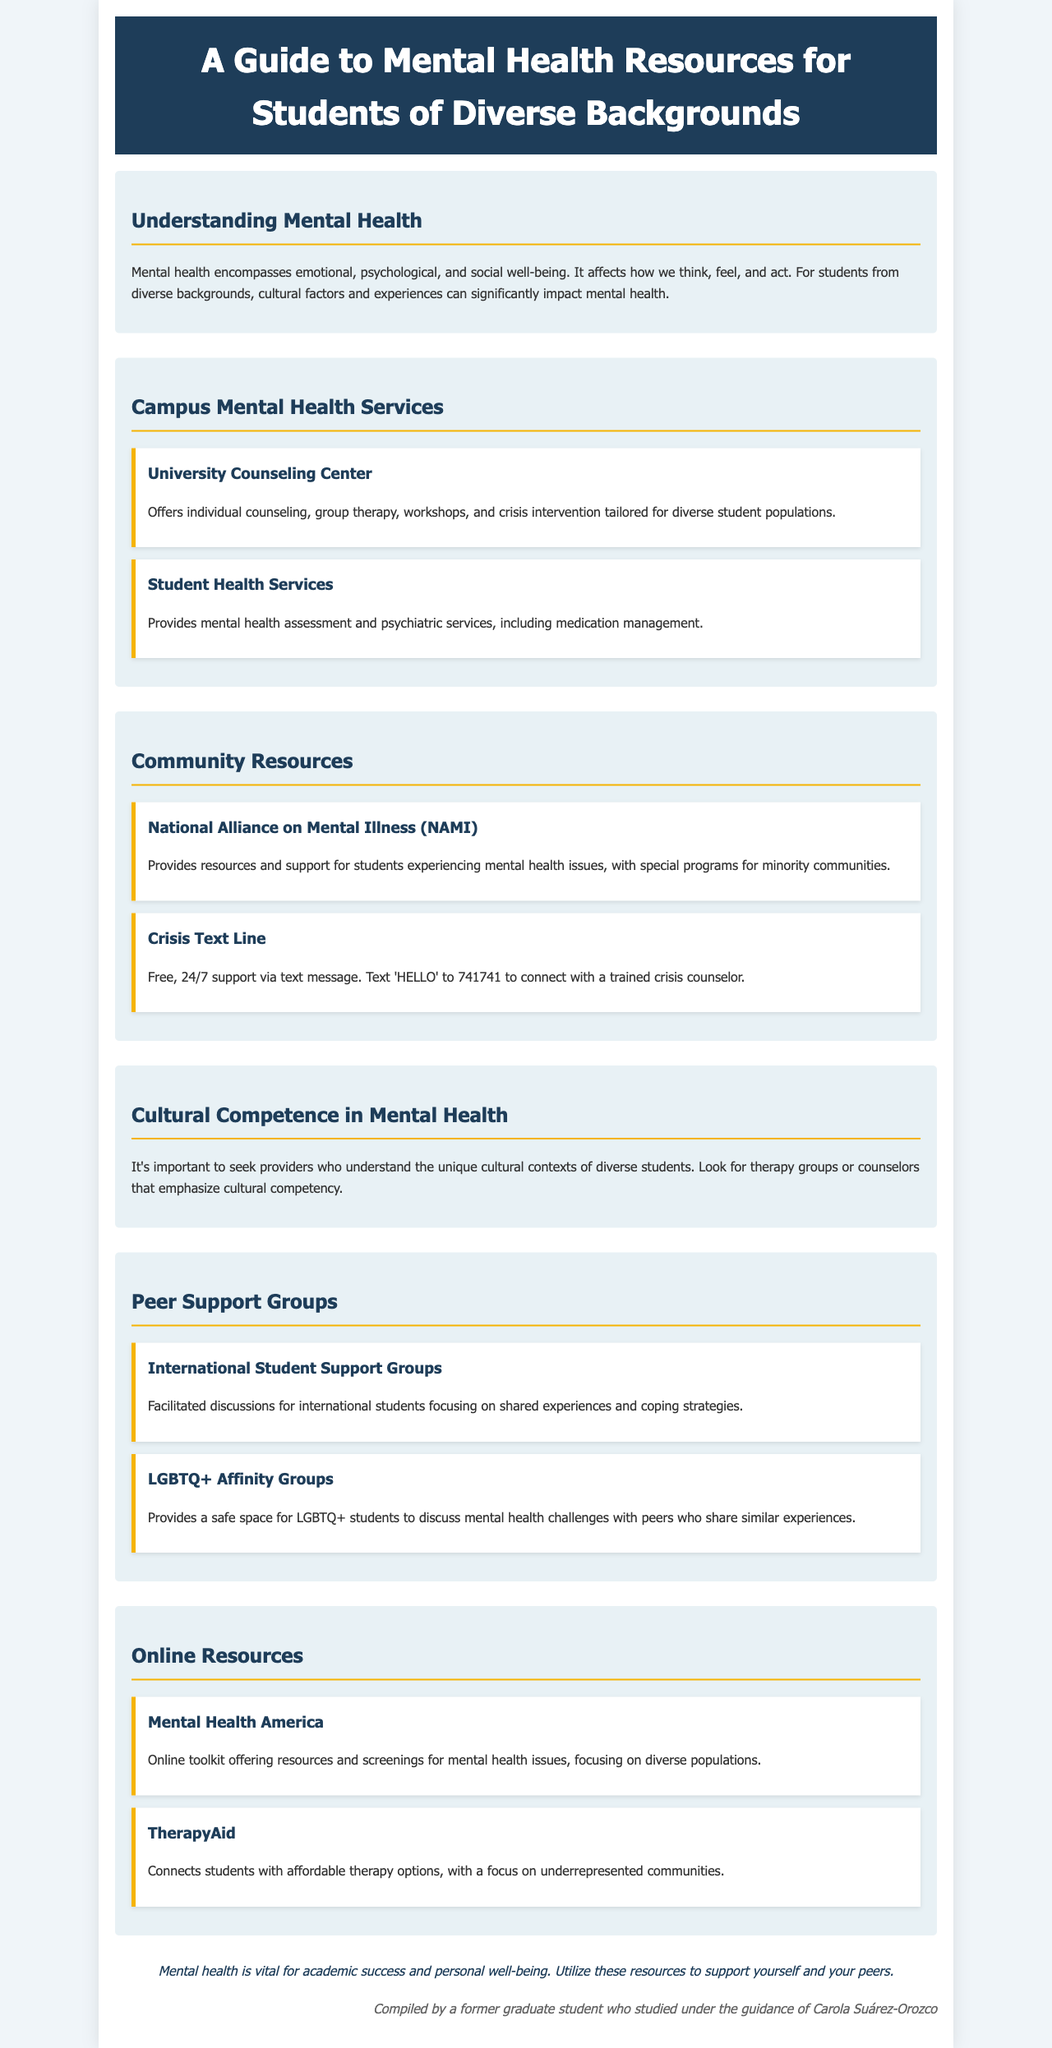What is the title of the document? The title is prominently displayed at the top of the document under the header section.
Answer: A Guide to Mental Health Resources for Students of Diverse Backgrounds What services does the University Counseling Center provide? The services provided by the University Counseling Center are detailed in the Campus Mental Health Services section.
Answer: Individual counseling, group therapy, workshops, and crisis intervention How can students connect with Crisis Text Line? The method to contact the Crisis Text Line is mentioned in the Community Resources section.
Answer: Text 'HELLO' to 741741 What type of support do the LGBTQ+ Affinity Groups offer? The type of support provided is described in the Peer Support Groups section.
Answer: A safe space for LGBTQ+ students to discuss mental health challenges Which organization offers an online toolkit focused on diverse populations? The organization is identified in the Online Resources section.
Answer: Mental Health America Why is cultural competence important in mental health? The importance of cultural competence is explained in the Cultural Competence in Mental Health section.
Answer: Understanding unique cultural contexts of diverse students How many community resources are listed in the document? The total number of community resources can be counted from the provided resource sections.
Answer: Two resources What does the document emphasize about mental health? The main emphasis related to mental health is mentioned at the end of the document.
Answer: Vital for academic success and personal well-being 